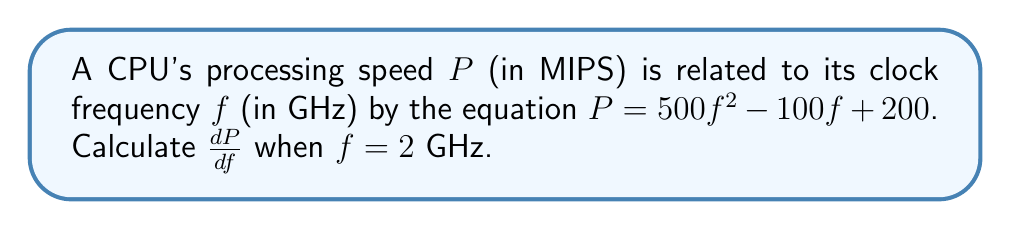Could you help me with this problem? To solve this problem, we need to follow these steps:

1) First, we need to find the derivative of $P$ with respect to $f$. Let's call this $\frac{dP}{df}$.

2) The function is $P = 500f^2 - 100f + 200$. To find $\frac{dP}{df}$, we apply the power rule and the constant rule of differentiation:

   $\frac{dP}{df} = 1000f - 100$

3) Now that we have the derivative, we need to evaluate it at $f = 2$ GHz:

   $\frac{dP}{df}|_{f=2} = 1000(2) - 100$
                         $= 2000 - 100$
                         $= 1900$

4) Therefore, when the clock frequency is 2 GHz, the rate of change of processing speed with respect to clock frequency is 1900 MIPS/GHz.

This result indicates that at a clock frequency of 2 GHz, a small increase in frequency will result in a significant increase in processing speed, highlighting the importance of hardware optimization in improving software performance.
Answer: 1900 MIPS/GHz 